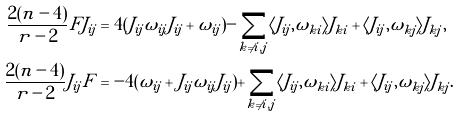<formula> <loc_0><loc_0><loc_500><loc_500>\frac { 2 ( n - 4 ) } { r - 2 } F J _ { i j } & = 4 ( J _ { i j } \omega _ { i j } J _ { i j } + \omega _ { i j } ) - \sum _ { k \neq i , j } \langle J _ { i j } , \omega _ { k i } \rangle J _ { k i } + \langle J _ { i j } , \omega _ { k j } \rangle J _ { k j } , \\ \frac { 2 ( n - 4 ) } { r - 2 } J _ { i j } F & = - 4 ( \omega _ { i j } + J _ { i j } \omega _ { i j } J _ { i j } ) + \sum _ { k \neq i , j } \langle J _ { i j } , \omega _ { k i } \rangle J _ { k i } + \langle J _ { i j } , \omega _ { k j } \rangle J _ { k j } .</formula> 